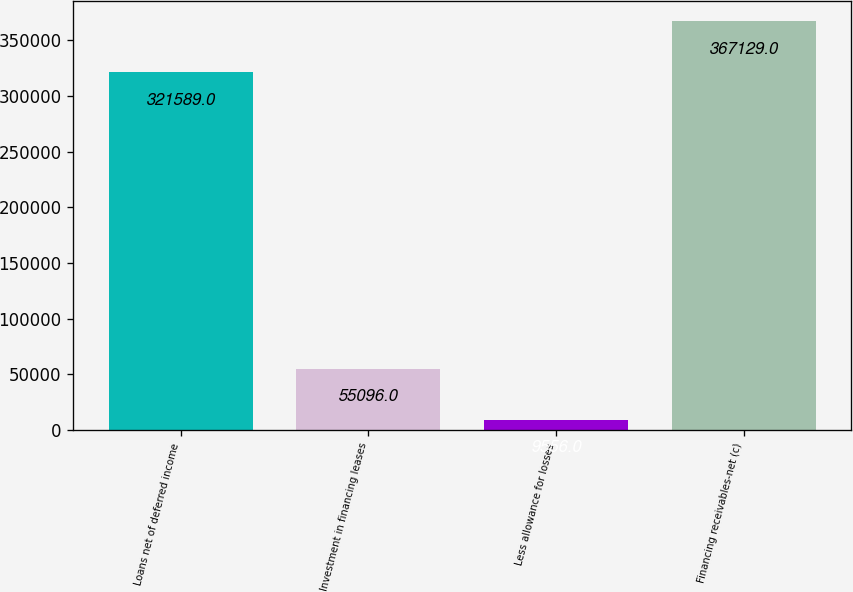Convert chart to OTSL. <chart><loc_0><loc_0><loc_500><loc_500><bar_chart><fcel>Loans net of deferred income<fcel>Investment in financing leases<fcel>Less allowance for losses<fcel>Financing receivables-net (c)<nl><fcel>321589<fcel>55096<fcel>9556<fcel>367129<nl></chart> 